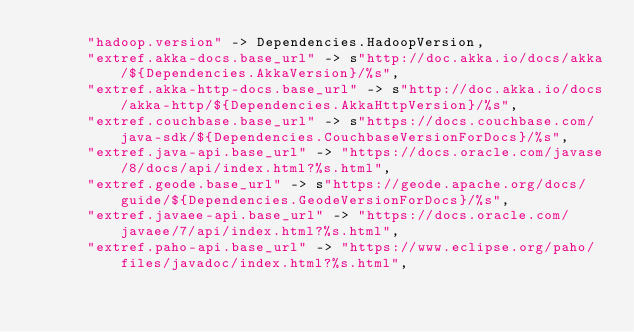<code> <loc_0><loc_0><loc_500><loc_500><_Scala_>      "hadoop.version" -> Dependencies.HadoopVersion,
      "extref.akka-docs.base_url" -> s"http://doc.akka.io/docs/akka/${Dependencies.AkkaVersion}/%s",
      "extref.akka-http-docs.base_url" -> s"http://doc.akka.io/docs/akka-http/${Dependencies.AkkaHttpVersion}/%s",
      "extref.couchbase.base_url" -> s"https://docs.couchbase.com/java-sdk/${Dependencies.CouchbaseVersionForDocs}/%s",
      "extref.java-api.base_url" -> "https://docs.oracle.com/javase/8/docs/api/index.html?%s.html",
      "extref.geode.base_url" -> s"https://geode.apache.org/docs/guide/${Dependencies.GeodeVersionForDocs}/%s",
      "extref.javaee-api.base_url" -> "https://docs.oracle.com/javaee/7/api/index.html?%s.html",
      "extref.paho-api.base_url" -> "https://www.eclipse.org/paho/files/javadoc/index.html?%s.html",</code> 